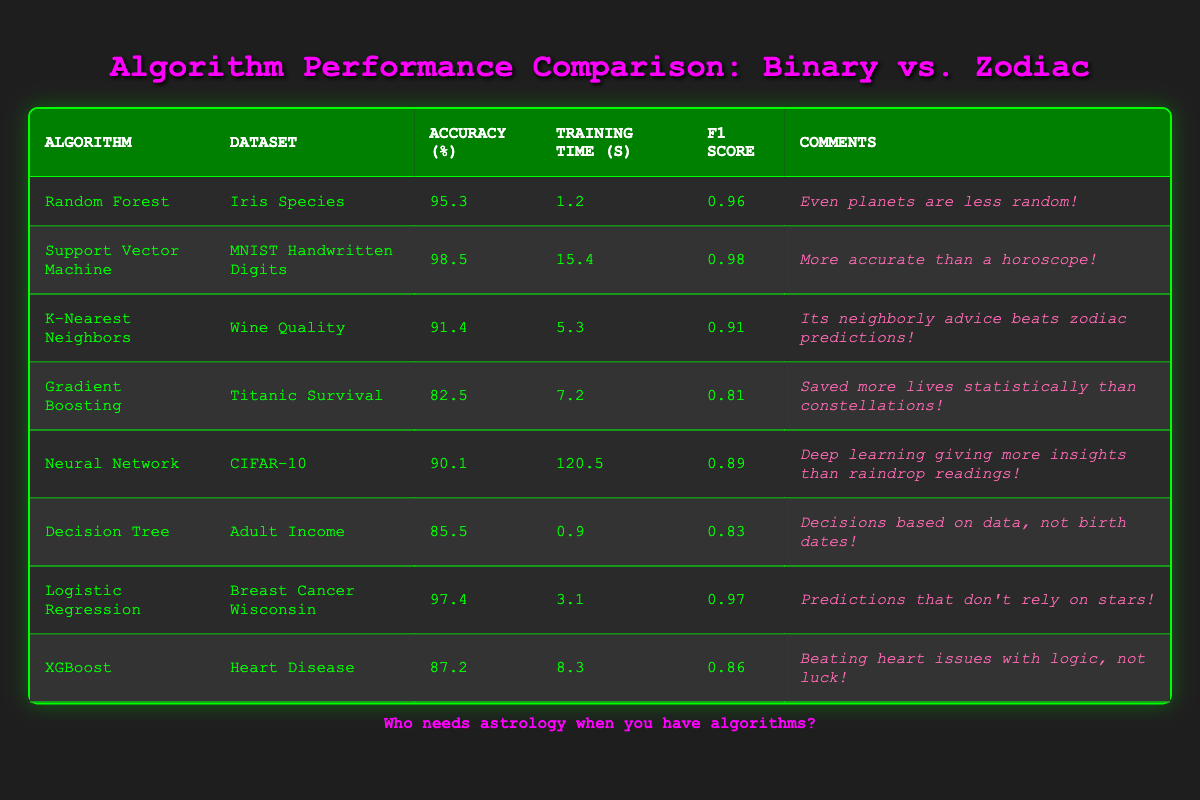What is the accuracy of the Support Vector Machine on the MNIST Handwritten Digits dataset? The accuracy for the Support Vector Machine on the MNIST Handwritten Digits dataset is directly provided in the table as 98.5.
Answer: 98.5 What is the training time for the Neural Network on the CIFAR-10 dataset? From the table, the training time for the Neural Network on the CIFAR-10 dataset is listed as 120.5 seconds.
Answer: 120.5 seconds Which algorithm has the highest accuracy? To find the highest accuracy, we compare the accuracy percentages from all algorithms in the table. The highest is 98.5 from the Support Vector Machine on MNIST Handwritten Digits.
Answer: 98.5 What is the average accuracy of the algorithms listed? We sum the accuracy values: 95.3 + 98.5 + 91.4 + 82.5 + 90.1 + 85.5 + 97.4 + 87.2 = 728.3. There are 8 algorithms, so we divide 728.3 by 8, giving an average of 91.04.
Answer: 91.04 Did any algorithm achieve an F1 score higher than 0.95? By checking the F1 score column, we see that both the Support Vector Machine and Logistic Regression have F1 scores of 0.98 and 0.97 respectively, which are higher than 0.95.
Answer: Yes Is the training time for K-Nearest Neighbors shorter than that of Gradient Boosting? The training time for K-Nearest Neighbors is 5.3 seconds and for Gradient Boosting it is 7.2 seconds. Therefore, K-Nearest Neighbors has a shorter training time.
Answer: Yes What is the difference in accuracy between Random Forest and Decision Tree? The accuracy of Random Forest is 95.3 and that of Decision Tree is 85.5. We find the difference by subtracting: 95.3 - 85.5 = 9.8.
Answer: 9.8 Which dataset has the lowest F1 score and what is its value? By inspecting the F1 scores, Gradient Boosting on the Titanic Survival dataset has the lowest F1 score of 0.81 among all the listed algorithms.
Answer: 0.81 What percentage of the algorithms have an accuracy over 90%? The algorithms with accuracy over 90% are: Random Forest (95.3), Support Vector Machine (98.5), K-Nearest Neighbors (91.4), Logistic Regression (97.4), and XGBoost (87.2). This gives us 5 out of 8 algorithms, which is 62.5%.
Answer: 62.5% 